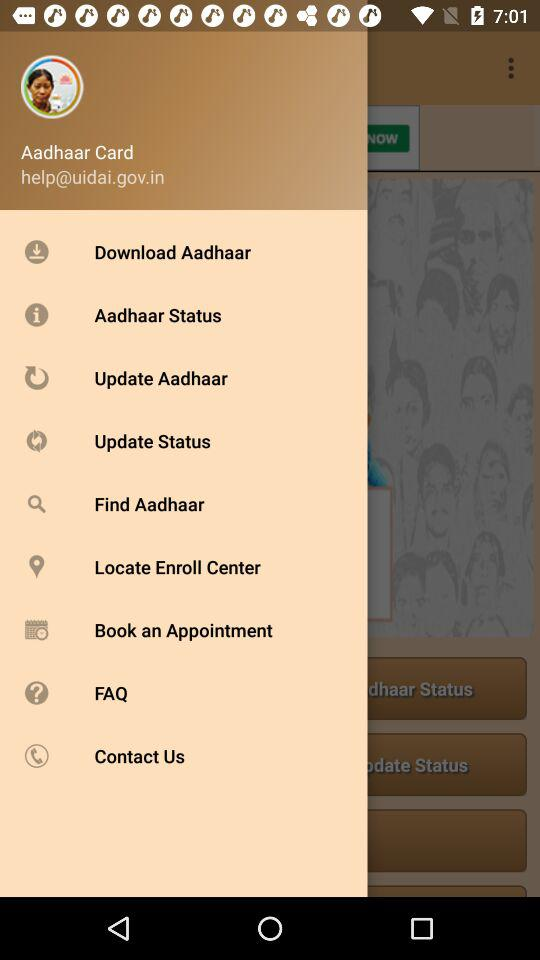What is the email address? The email address is help@uidai.gov.in. 